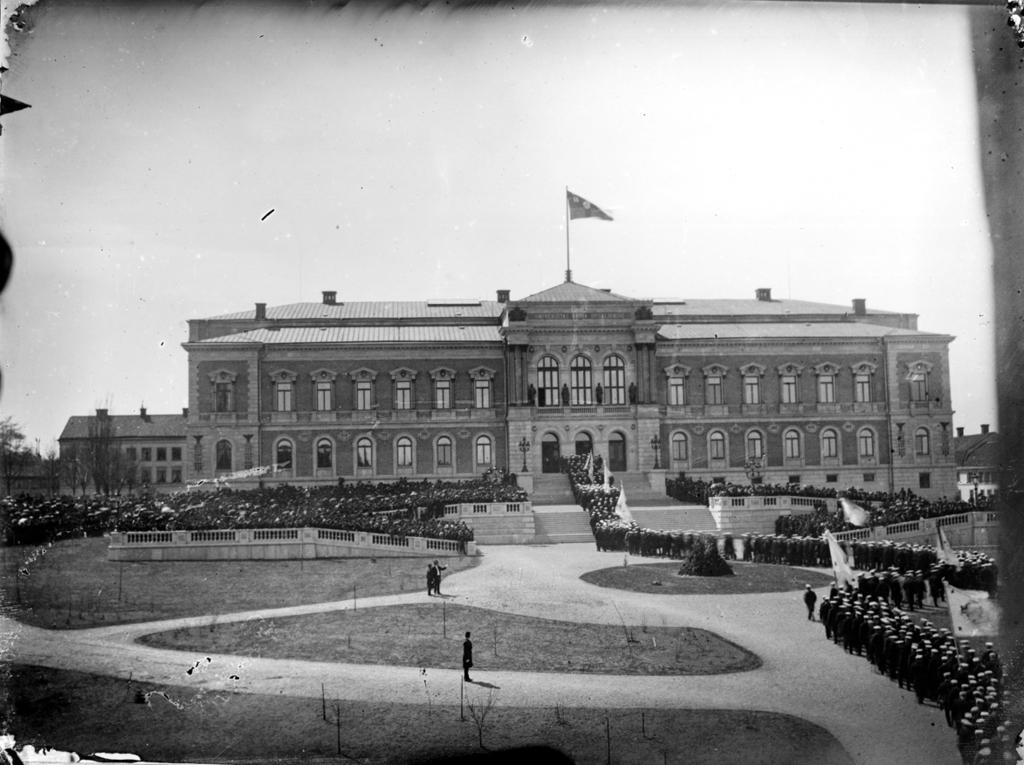How would you summarize this image in a sentence or two? In this image we can see a group of people standing on the ground holding flags in their hands. In the center of the image we can see some persons standing. In the background, we can see a building with group of windows and a flag on the roof and the sky. 